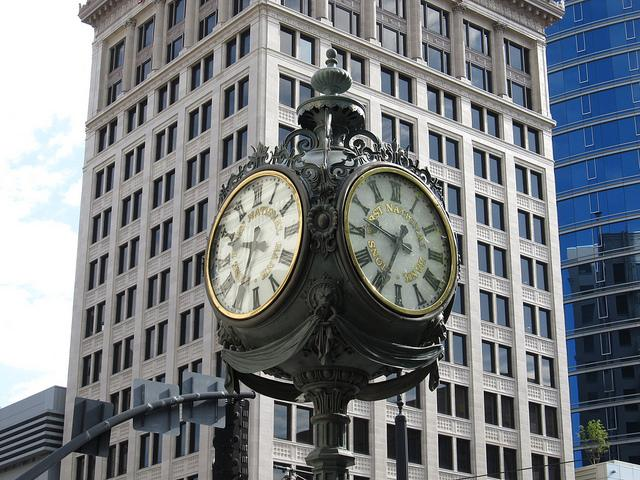What types of buildings are these? office buildings 